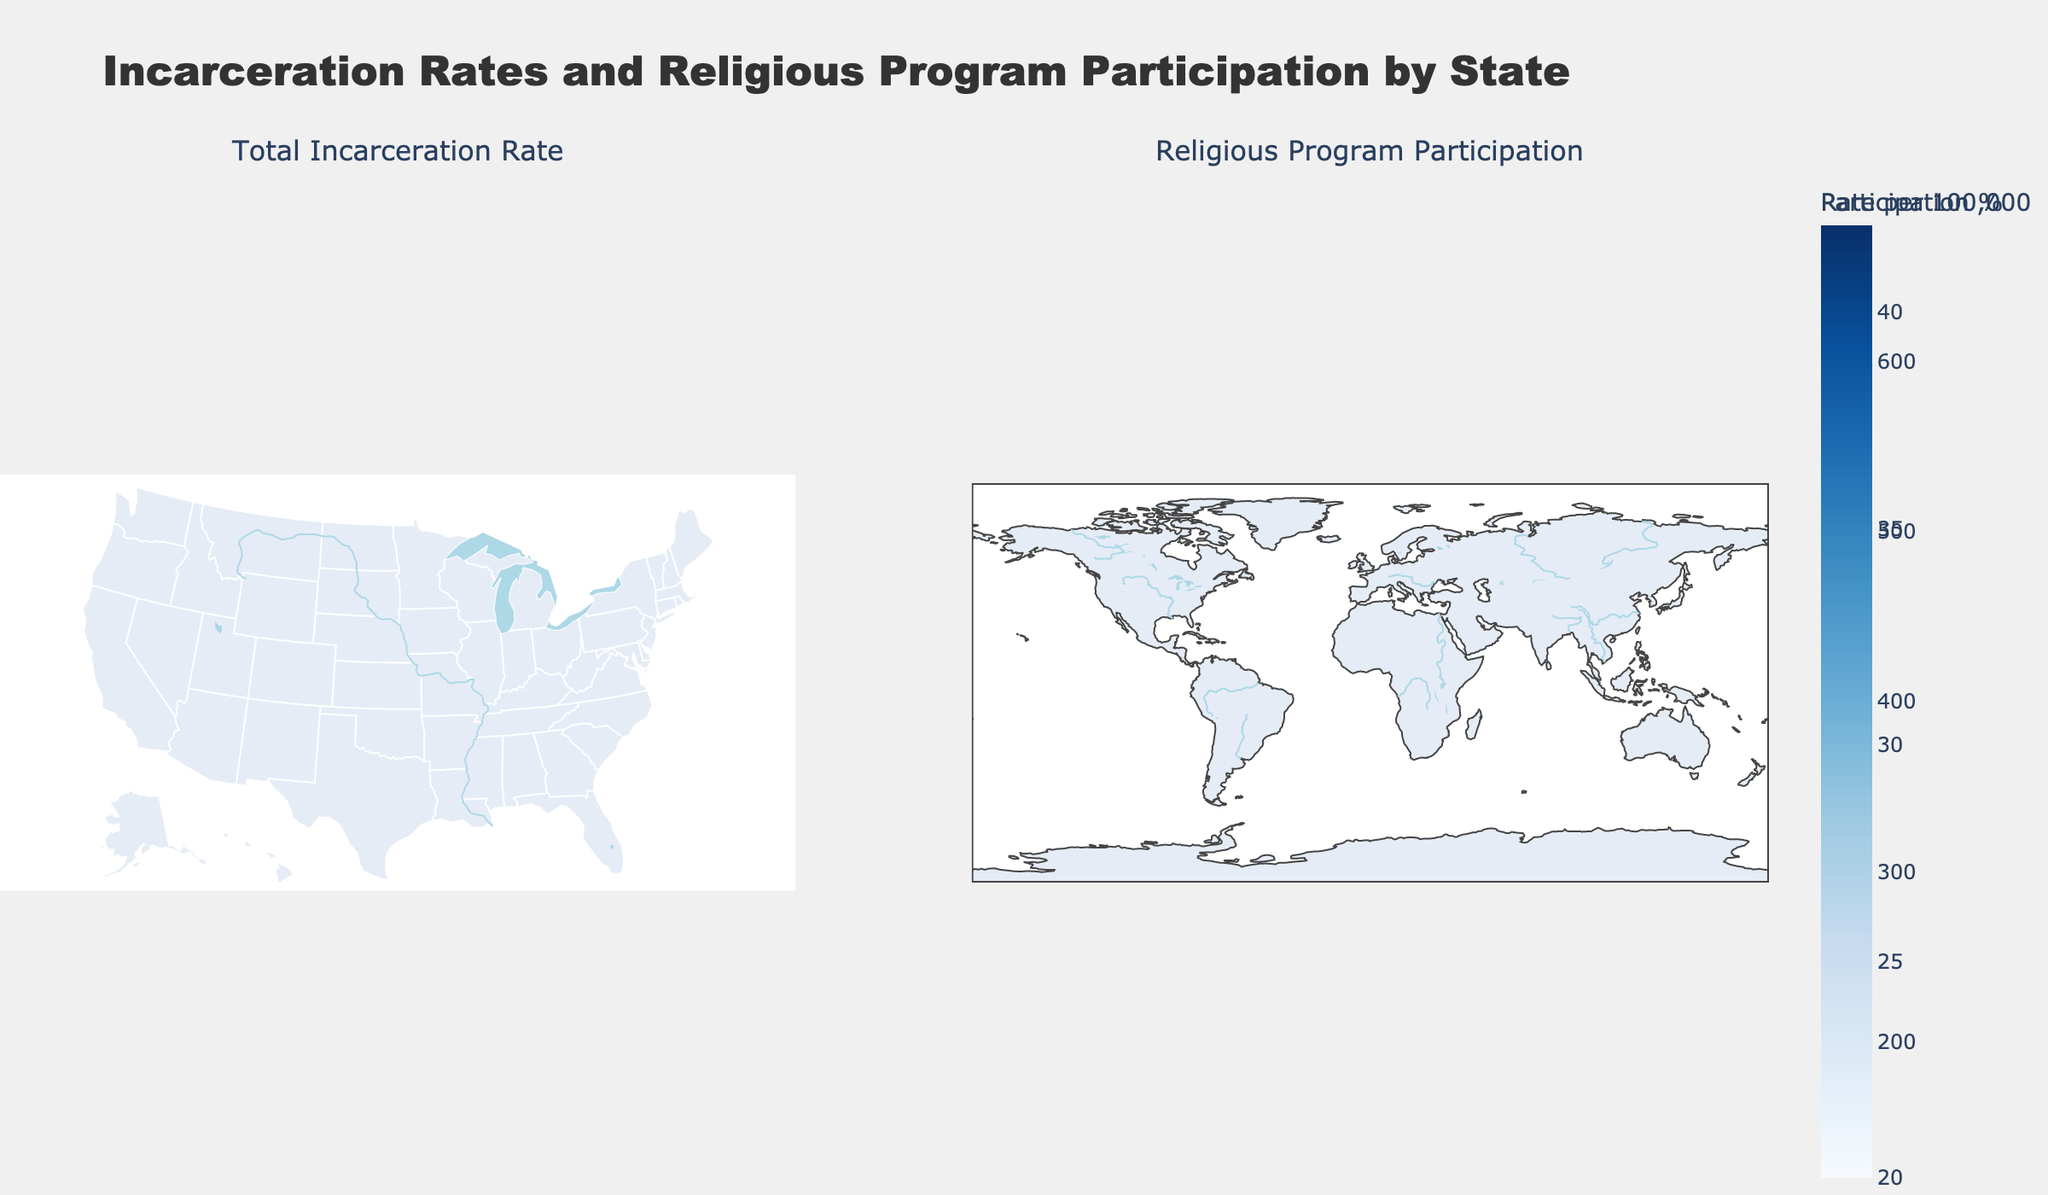What's the total incarceration rate in Louisiana? The first map displays total incarceration rates by state. Finding Louisiana on the map, we see that its total incarceration rate is 680 per 100,000 people.
Answer: 680 per 100,000 Which state has the highest religious program participation rate? The second map highlights different shades of blue that indicate religious program participation rates. Texas, with the darkest shade, has the highest participation rate at 42%.
Answer: Texas What's the difference between the total incarceration rates of New York and California? New York has a total incarceration rate of 240 per 100,000, while California has 330 per 100,000. The difference is calculated as 330 - 240.
Answer: 90 How does the Black incarceration rate compare between Arizona and Alabama? Arizona has a Black incarceration rate of 1680 per 100,000, and Alabama has 1410 per 100,000. Arizona's rate is significantly higher.
Answer: Arizona is higher Which state has a higher Hispanic incarceration rate: Texas or Florida? Texas has a Hispanic incarceration rate of 530 per 100,000, while Florida has 270 per 100,000. Texas has the higher rate.
Answer: Texas What's the average total incarceration rate of the states listed? Add all total incarceration rates: 680 + 580 + 640 + 610 + 570 + 500 + 440 + 520 + 330 + 240 + 120 + 140 = 5370. Divide this by the number of states (12).
Answer: 447.5 per 100,000 Which state in the plot has the lowest participation in religious programs? The second map, showing religious program participation, indicates Massachusetts in the lightest shade of blue, with a participation rate of 22%.
Answer: Massachusetts What's the difference in White incarceration rates between Mississippi and Oklahoma? Mississippi has a White incarceration rate of 360 per 100,000, and Oklahoma has 580 per 100,000. The difference is 580 - 360.
Answer: 220 per 100,000 Which state has a larger total incarceration rate, Georgia or Florida? Georgia's total incarceration rate is 500 per 100,000, while Florida's is 440 per 100,000. Georgia has the larger rate.
Answer: Georgia 